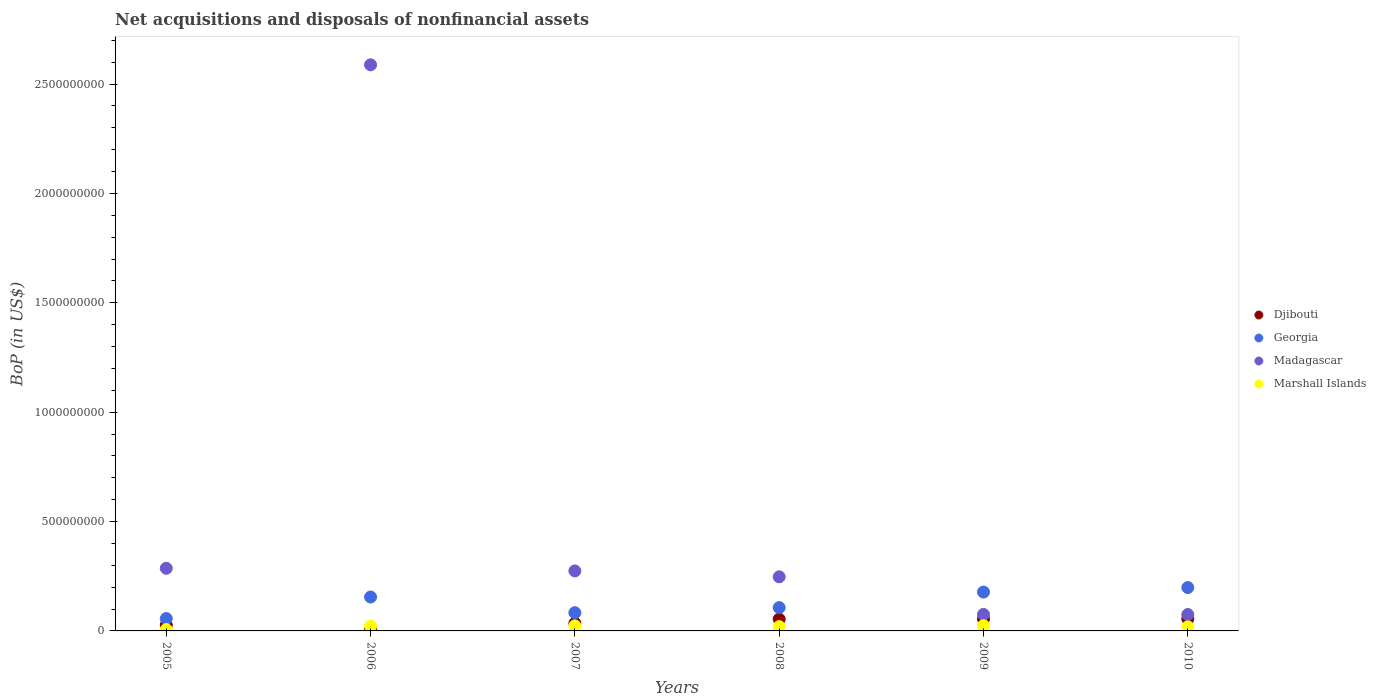How many different coloured dotlines are there?
Your answer should be compact. 4. Is the number of dotlines equal to the number of legend labels?
Make the answer very short. Yes. What is the Balance of Payments in Marshall Islands in 2006?
Make the answer very short. 2.23e+07. Across all years, what is the maximum Balance of Payments in Djibouti?
Provide a succinct answer. 5.53e+07. Across all years, what is the minimum Balance of Payments in Marshall Islands?
Keep it short and to the point. 6.08e+06. In which year was the Balance of Payments in Marshall Islands maximum?
Your response must be concise. 2009. What is the total Balance of Payments in Djibouti in the graph?
Keep it short and to the point. 2.36e+08. What is the difference between the Balance of Payments in Georgia in 2007 and that in 2010?
Ensure brevity in your answer.  -1.15e+08. What is the difference between the Balance of Payments in Marshall Islands in 2009 and the Balance of Payments in Madagascar in 2008?
Keep it short and to the point. -2.24e+08. What is the average Balance of Payments in Djibouti per year?
Offer a terse response. 3.93e+07. In the year 2005, what is the difference between the Balance of Payments in Marshall Islands and Balance of Payments in Georgia?
Provide a succinct answer. -5.04e+07. What is the ratio of the Balance of Payments in Madagascar in 2008 to that in 2010?
Your answer should be compact. 3.3. Is the Balance of Payments in Madagascar in 2005 less than that in 2007?
Offer a terse response. No. Is the difference between the Balance of Payments in Marshall Islands in 2005 and 2008 greater than the difference between the Balance of Payments in Georgia in 2005 and 2008?
Offer a very short reply. Yes. What is the difference between the highest and the second highest Balance of Payments in Madagascar?
Your answer should be very brief. 2.30e+09. What is the difference between the highest and the lowest Balance of Payments in Georgia?
Give a very brief answer. 1.42e+08. Is the sum of the Balance of Payments in Djibouti in 2006 and 2007 greater than the maximum Balance of Payments in Madagascar across all years?
Your answer should be compact. No. Does the Balance of Payments in Georgia monotonically increase over the years?
Provide a succinct answer. No. Is the Balance of Payments in Georgia strictly less than the Balance of Payments in Marshall Islands over the years?
Provide a short and direct response. No. How many dotlines are there?
Offer a very short reply. 4. How many years are there in the graph?
Ensure brevity in your answer.  6. Are the values on the major ticks of Y-axis written in scientific E-notation?
Offer a terse response. No. Does the graph contain any zero values?
Your response must be concise. No. Does the graph contain grids?
Provide a succinct answer. No. How are the legend labels stacked?
Offer a very short reply. Vertical. What is the title of the graph?
Keep it short and to the point. Net acquisitions and disposals of nonfinancial assets. Does "Austria" appear as one of the legend labels in the graph?
Provide a succinct answer. No. What is the label or title of the Y-axis?
Offer a very short reply. BoP (in US$). What is the BoP (in US$) of Djibouti in 2005?
Ensure brevity in your answer.  2.68e+07. What is the BoP (in US$) in Georgia in 2005?
Keep it short and to the point. 5.65e+07. What is the BoP (in US$) of Madagascar in 2005?
Offer a very short reply. 2.86e+08. What is the BoP (in US$) in Marshall Islands in 2005?
Your answer should be very brief. 6.08e+06. What is the BoP (in US$) of Djibouti in 2006?
Provide a succinct answer. 9.31e+06. What is the BoP (in US$) of Georgia in 2006?
Ensure brevity in your answer.  1.55e+08. What is the BoP (in US$) in Madagascar in 2006?
Make the answer very short. 2.59e+09. What is the BoP (in US$) in Marshall Islands in 2006?
Keep it short and to the point. 2.23e+07. What is the BoP (in US$) of Djibouti in 2007?
Your response must be concise. 3.53e+07. What is the BoP (in US$) of Georgia in 2007?
Offer a very short reply. 8.34e+07. What is the BoP (in US$) in Madagascar in 2007?
Ensure brevity in your answer.  2.74e+08. What is the BoP (in US$) in Marshall Islands in 2007?
Keep it short and to the point. 2.32e+07. What is the BoP (in US$) in Djibouti in 2008?
Your answer should be very brief. 5.37e+07. What is the BoP (in US$) in Georgia in 2008?
Your answer should be compact. 1.07e+08. What is the BoP (in US$) in Madagascar in 2008?
Your response must be concise. 2.47e+08. What is the BoP (in US$) of Marshall Islands in 2008?
Ensure brevity in your answer.  1.97e+07. What is the BoP (in US$) of Djibouti in 2009?
Offer a very short reply. 5.51e+07. What is the BoP (in US$) in Georgia in 2009?
Provide a short and direct response. 1.78e+08. What is the BoP (in US$) of Madagascar in 2009?
Offer a very short reply. 7.55e+07. What is the BoP (in US$) in Marshall Islands in 2009?
Your answer should be very brief. 2.38e+07. What is the BoP (in US$) in Djibouti in 2010?
Keep it short and to the point. 5.53e+07. What is the BoP (in US$) in Georgia in 2010?
Make the answer very short. 1.98e+08. What is the BoP (in US$) in Madagascar in 2010?
Keep it short and to the point. 7.49e+07. What is the BoP (in US$) in Marshall Islands in 2010?
Keep it short and to the point. 1.86e+07. Across all years, what is the maximum BoP (in US$) in Djibouti?
Your answer should be very brief. 5.53e+07. Across all years, what is the maximum BoP (in US$) in Georgia?
Keep it short and to the point. 1.98e+08. Across all years, what is the maximum BoP (in US$) in Madagascar?
Your answer should be very brief. 2.59e+09. Across all years, what is the maximum BoP (in US$) in Marshall Islands?
Your response must be concise. 2.38e+07. Across all years, what is the minimum BoP (in US$) in Djibouti?
Your answer should be very brief. 9.31e+06. Across all years, what is the minimum BoP (in US$) in Georgia?
Give a very brief answer. 5.65e+07. Across all years, what is the minimum BoP (in US$) in Madagascar?
Your answer should be compact. 7.49e+07. Across all years, what is the minimum BoP (in US$) in Marshall Islands?
Provide a succinct answer. 6.08e+06. What is the total BoP (in US$) of Djibouti in the graph?
Provide a short and direct response. 2.36e+08. What is the total BoP (in US$) in Georgia in the graph?
Provide a short and direct response. 7.77e+08. What is the total BoP (in US$) of Madagascar in the graph?
Provide a short and direct response. 3.55e+09. What is the total BoP (in US$) of Marshall Islands in the graph?
Provide a short and direct response. 1.14e+08. What is the difference between the BoP (in US$) in Djibouti in 2005 and that in 2006?
Give a very brief answer. 1.75e+07. What is the difference between the BoP (in US$) in Georgia in 2005 and that in 2006?
Your answer should be compact. -9.86e+07. What is the difference between the BoP (in US$) in Madagascar in 2005 and that in 2006?
Provide a succinct answer. -2.30e+09. What is the difference between the BoP (in US$) in Marshall Islands in 2005 and that in 2006?
Provide a succinct answer. -1.63e+07. What is the difference between the BoP (in US$) of Djibouti in 2005 and that in 2007?
Provide a succinct answer. -8.50e+06. What is the difference between the BoP (in US$) in Georgia in 2005 and that in 2007?
Your response must be concise. -2.69e+07. What is the difference between the BoP (in US$) in Madagascar in 2005 and that in 2007?
Keep it short and to the point. 1.21e+07. What is the difference between the BoP (in US$) of Marshall Islands in 2005 and that in 2007?
Your response must be concise. -1.72e+07. What is the difference between the BoP (in US$) in Djibouti in 2005 and that in 2008?
Ensure brevity in your answer.  -2.70e+07. What is the difference between the BoP (in US$) in Georgia in 2005 and that in 2008?
Offer a terse response. -5.01e+07. What is the difference between the BoP (in US$) in Madagascar in 2005 and that in 2008?
Ensure brevity in your answer.  3.89e+07. What is the difference between the BoP (in US$) in Marshall Islands in 2005 and that in 2008?
Offer a terse response. -1.36e+07. What is the difference between the BoP (in US$) in Djibouti in 2005 and that in 2009?
Your answer should be compact. -2.84e+07. What is the difference between the BoP (in US$) of Georgia in 2005 and that in 2009?
Provide a short and direct response. -1.21e+08. What is the difference between the BoP (in US$) in Madagascar in 2005 and that in 2009?
Your answer should be compact. 2.11e+08. What is the difference between the BoP (in US$) of Marshall Islands in 2005 and that in 2009?
Offer a terse response. -1.77e+07. What is the difference between the BoP (in US$) of Djibouti in 2005 and that in 2010?
Make the answer very short. -2.86e+07. What is the difference between the BoP (in US$) in Georgia in 2005 and that in 2010?
Provide a short and direct response. -1.42e+08. What is the difference between the BoP (in US$) in Madagascar in 2005 and that in 2010?
Ensure brevity in your answer.  2.11e+08. What is the difference between the BoP (in US$) of Marshall Islands in 2005 and that in 2010?
Provide a succinct answer. -1.26e+07. What is the difference between the BoP (in US$) in Djibouti in 2006 and that in 2007?
Offer a very short reply. -2.60e+07. What is the difference between the BoP (in US$) in Georgia in 2006 and that in 2007?
Offer a very short reply. 7.17e+07. What is the difference between the BoP (in US$) of Madagascar in 2006 and that in 2007?
Ensure brevity in your answer.  2.31e+09. What is the difference between the BoP (in US$) in Marshall Islands in 2006 and that in 2007?
Offer a terse response. -9.06e+05. What is the difference between the BoP (in US$) in Djibouti in 2006 and that in 2008?
Offer a very short reply. -4.44e+07. What is the difference between the BoP (in US$) in Georgia in 2006 and that in 2008?
Your response must be concise. 4.85e+07. What is the difference between the BoP (in US$) in Madagascar in 2006 and that in 2008?
Your response must be concise. 2.34e+09. What is the difference between the BoP (in US$) of Marshall Islands in 2006 and that in 2008?
Give a very brief answer. 2.67e+06. What is the difference between the BoP (in US$) in Djibouti in 2006 and that in 2009?
Offer a terse response. -4.58e+07. What is the difference between the BoP (in US$) of Georgia in 2006 and that in 2009?
Your response must be concise. -2.25e+07. What is the difference between the BoP (in US$) in Madagascar in 2006 and that in 2009?
Provide a succinct answer. 2.51e+09. What is the difference between the BoP (in US$) of Marshall Islands in 2006 and that in 2009?
Make the answer very short. -1.47e+06. What is the difference between the BoP (in US$) of Djibouti in 2006 and that in 2010?
Your answer should be very brief. -4.60e+07. What is the difference between the BoP (in US$) in Georgia in 2006 and that in 2010?
Provide a short and direct response. -4.32e+07. What is the difference between the BoP (in US$) in Madagascar in 2006 and that in 2010?
Give a very brief answer. 2.51e+09. What is the difference between the BoP (in US$) in Marshall Islands in 2006 and that in 2010?
Ensure brevity in your answer.  3.70e+06. What is the difference between the BoP (in US$) in Djibouti in 2007 and that in 2008?
Provide a short and direct response. -1.85e+07. What is the difference between the BoP (in US$) in Georgia in 2007 and that in 2008?
Your answer should be compact. -2.32e+07. What is the difference between the BoP (in US$) of Madagascar in 2007 and that in 2008?
Make the answer very short. 2.68e+07. What is the difference between the BoP (in US$) of Marshall Islands in 2007 and that in 2008?
Provide a short and direct response. 3.57e+06. What is the difference between the BoP (in US$) of Djibouti in 2007 and that in 2009?
Your answer should be very brief. -1.99e+07. What is the difference between the BoP (in US$) of Georgia in 2007 and that in 2009?
Make the answer very short. -9.42e+07. What is the difference between the BoP (in US$) of Madagascar in 2007 and that in 2009?
Give a very brief answer. 1.99e+08. What is the difference between the BoP (in US$) of Marshall Islands in 2007 and that in 2009?
Provide a succinct answer. -5.65e+05. What is the difference between the BoP (in US$) in Djibouti in 2007 and that in 2010?
Ensure brevity in your answer.  -2.00e+07. What is the difference between the BoP (in US$) in Georgia in 2007 and that in 2010?
Provide a succinct answer. -1.15e+08. What is the difference between the BoP (in US$) in Madagascar in 2007 and that in 2010?
Ensure brevity in your answer.  1.99e+08. What is the difference between the BoP (in US$) of Marshall Islands in 2007 and that in 2010?
Keep it short and to the point. 4.61e+06. What is the difference between the BoP (in US$) of Djibouti in 2008 and that in 2009?
Your response must be concise. -1.39e+06. What is the difference between the BoP (in US$) of Georgia in 2008 and that in 2009?
Offer a terse response. -7.10e+07. What is the difference between the BoP (in US$) of Madagascar in 2008 and that in 2009?
Your response must be concise. 1.72e+08. What is the difference between the BoP (in US$) of Marshall Islands in 2008 and that in 2009?
Give a very brief answer. -4.14e+06. What is the difference between the BoP (in US$) of Djibouti in 2008 and that in 2010?
Provide a short and direct response. -1.58e+06. What is the difference between the BoP (in US$) in Georgia in 2008 and that in 2010?
Give a very brief answer. -9.17e+07. What is the difference between the BoP (in US$) of Madagascar in 2008 and that in 2010?
Provide a succinct answer. 1.72e+08. What is the difference between the BoP (in US$) in Marshall Islands in 2008 and that in 2010?
Your answer should be compact. 1.04e+06. What is the difference between the BoP (in US$) in Djibouti in 2009 and that in 2010?
Provide a succinct answer. -1.86e+05. What is the difference between the BoP (in US$) of Georgia in 2009 and that in 2010?
Make the answer very short. -2.07e+07. What is the difference between the BoP (in US$) in Madagascar in 2009 and that in 2010?
Your answer should be compact. 5.31e+05. What is the difference between the BoP (in US$) in Marshall Islands in 2009 and that in 2010?
Ensure brevity in your answer.  5.17e+06. What is the difference between the BoP (in US$) of Djibouti in 2005 and the BoP (in US$) of Georgia in 2006?
Provide a succinct answer. -1.28e+08. What is the difference between the BoP (in US$) of Djibouti in 2005 and the BoP (in US$) of Madagascar in 2006?
Your answer should be very brief. -2.56e+09. What is the difference between the BoP (in US$) in Djibouti in 2005 and the BoP (in US$) in Marshall Islands in 2006?
Make the answer very short. 4.43e+06. What is the difference between the BoP (in US$) in Georgia in 2005 and the BoP (in US$) in Madagascar in 2006?
Give a very brief answer. -2.53e+09. What is the difference between the BoP (in US$) of Georgia in 2005 and the BoP (in US$) of Marshall Islands in 2006?
Your response must be concise. 3.41e+07. What is the difference between the BoP (in US$) in Madagascar in 2005 and the BoP (in US$) in Marshall Islands in 2006?
Provide a succinct answer. 2.64e+08. What is the difference between the BoP (in US$) in Djibouti in 2005 and the BoP (in US$) in Georgia in 2007?
Your answer should be very brief. -5.66e+07. What is the difference between the BoP (in US$) in Djibouti in 2005 and the BoP (in US$) in Madagascar in 2007?
Offer a terse response. -2.47e+08. What is the difference between the BoP (in US$) in Djibouti in 2005 and the BoP (in US$) in Marshall Islands in 2007?
Ensure brevity in your answer.  3.52e+06. What is the difference between the BoP (in US$) of Georgia in 2005 and the BoP (in US$) of Madagascar in 2007?
Give a very brief answer. -2.18e+08. What is the difference between the BoP (in US$) of Georgia in 2005 and the BoP (in US$) of Marshall Islands in 2007?
Make the answer very short. 3.32e+07. What is the difference between the BoP (in US$) of Madagascar in 2005 and the BoP (in US$) of Marshall Islands in 2007?
Your answer should be compact. 2.63e+08. What is the difference between the BoP (in US$) in Djibouti in 2005 and the BoP (in US$) in Georgia in 2008?
Provide a succinct answer. -7.99e+07. What is the difference between the BoP (in US$) of Djibouti in 2005 and the BoP (in US$) of Madagascar in 2008?
Your response must be concise. -2.21e+08. What is the difference between the BoP (in US$) of Djibouti in 2005 and the BoP (in US$) of Marshall Islands in 2008?
Your response must be concise. 7.09e+06. What is the difference between the BoP (in US$) of Georgia in 2005 and the BoP (in US$) of Madagascar in 2008?
Offer a terse response. -1.91e+08. What is the difference between the BoP (in US$) of Georgia in 2005 and the BoP (in US$) of Marshall Islands in 2008?
Provide a succinct answer. 3.68e+07. What is the difference between the BoP (in US$) of Madagascar in 2005 and the BoP (in US$) of Marshall Islands in 2008?
Give a very brief answer. 2.67e+08. What is the difference between the BoP (in US$) in Djibouti in 2005 and the BoP (in US$) in Georgia in 2009?
Provide a succinct answer. -1.51e+08. What is the difference between the BoP (in US$) of Djibouti in 2005 and the BoP (in US$) of Madagascar in 2009?
Offer a terse response. -4.87e+07. What is the difference between the BoP (in US$) of Djibouti in 2005 and the BoP (in US$) of Marshall Islands in 2009?
Provide a short and direct response. 2.96e+06. What is the difference between the BoP (in US$) in Georgia in 2005 and the BoP (in US$) in Madagascar in 2009?
Ensure brevity in your answer.  -1.90e+07. What is the difference between the BoP (in US$) in Georgia in 2005 and the BoP (in US$) in Marshall Islands in 2009?
Give a very brief answer. 3.27e+07. What is the difference between the BoP (in US$) of Madagascar in 2005 and the BoP (in US$) of Marshall Islands in 2009?
Your response must be concise. 2.63e+08. What is the difference between the BoP (in US$) of Djibouti in 2005 and the BoP (in US$) of Georgia in 2010?
Your answer should be compact. -1.72e+08. What is the difference between the BoP (in US$) of Djibouti in 2005 and the BoP (in US$) of Madagascar in 2010?
Your response must be concise. -4.82e+07. What is the difference between the BoP (in US$) of Djibouti in 2005 and the BoP (in US$) of Marshall Islands in 2010?
Ensure brevity in your answer.  8.13e+06. What is the difference between the BoP (in US$) in Georgia in 2005 and the BoP (in US$) in Madagascar in 2010?
Provide a short and direct response. -1.85e+07. What is the difference between the BoP (in US$) of Georgia in 2005 and the BoP (in US$) of Marshall Islands in 2010?
Give a very brief answer. 3.78e+07. What is the difference between the BoP (in US$) in Madagascar in 2005 and the BoP (in US$) in Marshall Islands in 2010?
Your answer should be very brief. 2.68e+08. What is the difference between the BoP (in US$) in Djibouti in 2006 and the BoP (in US$) in Georgia in 2007?
Your answer should be compact. -7.41e+07. What is the difference between the BoP (in US$) in Djibouti in 2006 and the BoP (in US$) in Madagascar in 2007?
Provide a succinct answer. -2.65e+08. What is the difference between the BoP (in US$) of Djibouti in 2006 and the BoP (in US$) of Marshall Islands in 2007?
Keep it short and to the point. -1.39e+07. What is the difference between the BoP (in US$) in Georgia in 2006 and the BoP (in US$) in Madagascar in 2007?
Your answer should be compact. -1.19e+08. What is the difference between the BoP (in US$) of Georgia in 2006 and the BoP (in US$) of Marshall Islands in 2007?
Give a very brief answer. 1.32e+08. What is the difference between the BoP (in US$) in Madagascar in 2006 and the BoP (in US$) in Marshall Islands in 2007?
Give a very brief answer. 2.56e+09. What is the difference between the BoP (in US$) of Djibouti in 2006 and the BoP (in US$) of Georgia in 2008?
Offer a very short reply. -9.73e+07. What is the difference between the BoP (in US$) in Djibouti in 2006 and the BoP (in US$) in Madagascar in 2008?
Provide a short and direct response. -2.38e+08. What is the difference between the BoP (in US$) in Djibouti in 2006 and the BoP (in US$) in Marshall Islands in 2008?
Give a very brief answer. -1.04e+07. What is the difference between the BoP (in US$) of Georgia in 2006 and the BoP (in US$) of Madagascar in 2008?
Your response must be concise. -9.23e+07. What is the difference between the BoP (in US$) of Georgia in 2006 and the BoP (in US$) of Marshall Islands in 2008?
Provide a short and direct response. 1.35e+08. What is the difference between the BoP (in US$) of Madagascar in 2006 and the BoP (in US$) of Marshall Islands in 2008?
Give a very brief answer. 2.57e+09. What is the difference between the BoP (in US$) in Djibouti in 2006 and the BoP (in US$) in Georgia in 2009?
Your answer should be compact. -1.68e+08. What is the difference between the BoP (in US$) of Djibouti in 2006 and the BoP (in US$) of Madagascar in 2009?
Your answer should be compact. -6.62e+07. What is the difference between the BoP (in US$) in Djibouti in 2006 and the BoP (in US$) in Marshall Islands in 2009?
Offer a terse response. -1.45e+07. What is the difference between the BoP (in US$) in Georgia in 2006 and the BoP (in US$) in Madagascar in 2009?
Make the answer very short. 7.96e+07. What is the difference between the BoP (in US$) of Georgia in 2006 and the BoP (in US$) of Marshall Islands in 2009?
Your answer should be compact. 1.31e+08. What is the difference between the BoP (in US$) in Madagascar in 2006 and the BoP (in US$) in Marshall Islands in 2009?
Your answer should be compact. 2.56e+09. What is the difference between the BoP (in US$) of Djibouti in 2006 and the BoP (in US$) of Georgia in 2010?
Ensure brevity in your answer.  -1.89e+08. What is the difference between the BoP (in US$) in Djibouti in 2006 and the BoP (in US$) in Madagascar in 2010?
Your response must be concise. -6.56e+07. What is the difference between the BoP (in US$) in Djibouti in 2006 and the BoP (in US$) in Marshall Islands in 2010?
Offer a very short reply. -9.33e+06. What is the difference between the BoP (in US$) of Georgia in 2006 and the BoP (in US$) of Madagascar in 2010?
Keep it short and to the point. 8.02e+07. What is the difference between the BoP (in US$) in Georgia in 2006 and the BoP (in US$) in Marshall Islands in 2010?
Offer a very short reply. 1.36e+08. What is the difference between the BoP (in US$) in Madagascar in 2006 and the BoP (in US$) in Marshall Islands in 2010?
Provide a succinct answer. 2.57e+09. What is the difference between the BoP (in US$) in Djibouti in 2007 and the BoP (in US$) in Georgia in 2008?
Provide a short and direct response. -7.14e+07. What is the difference between the BoP (in US$) in Djibouti in 2007 and the BoP (in US$) in Madagascar in 2008?
Ensure brevity in your answer.  -2.12e+08. What is the difference between the BoP (in US$) in Djibouti in 2007 and the BoP (in US$) in Marshall Islands in 2008?
Your answer should be compact. 1.56e+07. What is the difference between the BoP (in US$) in Georgia in 2007 and the BoP (in US$) in Madagascar in 2008?
Your answer should be compact. -1.64e+08. What is the difference between the BoP (in US$) of Georgia in 2007 and the BoP (in US$) of Marshall Islands in 2008?
Make the answer very short. 6.37e+07. What is the difference between the BoP (in US$) of Madagascar in 2007 and the BoP (in US$) of Marshall Islands in 2008?
Your answer should be compact. 2.55e+08. What is the difference between the BoP (in US$) of Djibouti in 2007 and the BoP (in US$) of Georgia in 2009?
Your answer should be very brief. -1.42e+08. What is the difference between the BoP (in US$) in Djibouti in 2007 and the BoP (in US$) in Madagascar in 2009?
Provide a short and direct response. -4.02e+07. What is the difference between the BoP (in US$) of Djibouti in 2007 and the BoP (in US$) of Marshall Islands in 2009?
Ensure brevity in your answer.  1.15e+07. What is the difference between the BoP (in US$) in Georgia in 2007 and the BoP (in US$) in Madagascar in 2009?
Your answer should be very brief. 7.93e+06. What is the difference between the BoP (in US$) of Georgia in 2007 and the BoP (in US$) of Marshall Islands in 2009?
Your answer should be very brief. 5.96e+07. What is the difference between the BoP (in US$) in Madagascar in 2007 and the BoP (in US$) in Marshall Islands in 2009?
Provide a succinct answer. 2.50e+08. What is the difference between the BoP (in US$) in Djibouti in 2007 and the BoP (in US$) in Georgia in 2010?
Make the answer very short. -1.63e+08. What is the difference between the BoP (in US$) in Djibouti in 2007 and the BoP (in US$) in Madagascar in 2010?
Make the answer very short. -3.97e+07. What is the difference between the BoP (in US$) in Djibouti in 2007 and the BoP (in US$) in Marshall Islands in 2010?
Your answer should be compact. 1.66e+07. What is the difference between the BoP (in US$) of Georgia in 2007 and the BoP (in US$) of Madagascar in 2010?
Provide a succinct answer. 8.46e+06. What is the difference between the BoP (in US$) in Georgia in 2007 and the BoP (in US$) in Marshall Islands in 2010?
Provide a succinct answer. 6.48e+07. What is the difference between the BoP (in US$) of Madagascar in 2007 and the BoP (in US$) of Marshall Islands in 2010?
Your answer should be compact. 2.56e+08. What is the difference between the BoP (in US$) of Djibouti in 2008 and the BoP (in US$) of Georgia in 2009?
Ensure brevity in your answer.  -1.24e+08. What is the difference between the BoP (in US$) in Djibouti in 2008 and the BoP (in US$) in Madagascar in 2009?
Your answer should be compact. -2.17e+07. What is the difference between the BoP (in US$) in Djibouti in 2008 and the BoP (in US$) in Marshall Islands in 2009?
Give a very brief answer. 2.99e+07. What is the difference between the BoP (in US$) of Georgia in 2008 and the BoP (in US$) of Madagascar in 2009?
Keep it short and to the point. 3.12e+07. What is the difference between the BoP (in US$) of Georgia in 2008 and the BoP (in US$) of Marshall Islands in 2009?
Your answer should be compact. 8.28e+07. What is the difference between the BoP (in US$) in Madagascar in 2008 and the BoP (in US$) in Marshall Islands in 2009?
Your answer should be compact. 2.24e+08. What is the difference between the BoP (in US$) of Djibouti in 2008 and the BoP (in US$) of Georgia in 2010?
Your answer should be compact. -1.45e+08. What is the difference between the BoP (in US$) of Djibouti in 2008 and the BoP (in US$) of Madagascar in 2010?
Your response must be concise. -2.12e+07. What is the difference between the BoP (in US$) of Djibouti in 2008 and the BoP (in US$) of Marshall Islands in 2010?
Ensure brevity in your answer.  3.51e+07. What is the difference between the BoP (in US$) of Georgia in 2008 and the BoP (in US$) of Madagascar in 2010?
Your answer should be very brief. 3.17e+07. What is the difference between the BoP (in US$) in Georgia in 2008 and the BoP (in US$) in Marshall Islands in 2010?
Offer a terse response. 8.80e+07. What is the difference between the BoP (in US$) of Madagascar in 2008 and the BoP (in US$) of Marshall Islands in 2010?
Keep it short and to the point. 2.29e+08. What is the difference between the BoP (in US$) of Djibouti in 2009 and the BoP (in US$) of Georgia in 2010?
Offer a very short reply. -1.43e+08. What is the difference between the BoP (in US$) in Djibouti in 2009 and the BoP (in US$) in Madagascar in 2010?
Your answer should be very brief. -1.98e+07. What is the difference between the BoP (in US$) in Djibouti in 2009 and the BoP (in US$) in Marshall Islands in 2010?
Give a very brief answer. 3.65e+07. What is the difference between the BoP (in US$) in Georgia in 2009 and the BoP (in US$) in Madagascar in 2010?
Your answer should be compact. 1.03e+08. What is the difference between the BoP (in US$) in Georgia in 2009 and the BoP (in US$) in Marshall Islands in 2010?
Ensure brevity in your answer.  1.59e+08. What is the difference between the BoP (in US$) of Madagascar in 2009 and the BoP (in US$) of Marshall Islands in 2010?
Ensure brevity in your answer.  5.68e+07. What is the average BoP (in US$) in Djibouti per year?
Your response must be concise. 3.93e+07. What is the average BoP (in US$) in Georgia per year?
Keep it short and to the point. 1.30e+08. What is the average BoP (in US$) in Madagascar per year?
Your response must be concise. 5.91e+08. What is the average BoP (in US$) of Marshall Islands per year?
Keep it short and to the point. 1.90e+07. In the year 2005, what is the difference between the BoP (in US$) in Djibouti and BoP (in US$) in Georgia?
Give a very brief answer. -2.97e+07. In the year 2005, what is the difference between the BoP (in US$) of Djibouti and BoP (in US$) of Madagascar?
Make the answer very short. -2.60e+08. In the year 2005, what is the difference between the BoP (in US$) of Djibouti and BoP (in US$) of Marshall Islands?
Make the answer very short. 2.07e+07. In the year 2005, what is the difference between the BoP (in US$) in Georgia and BoP (in US$) in Madagascar?
Make the answer very short. -2.30e+08. In the year 2005, what is the difference between the BoP (in US$) of Georgia and BoP (in US$) of Marshall Islands?
Ensure brevity in your answer.  5.04e+07. In the year 2005, what is the difference between the BoP (in US$) in Madagascar and BoP (in US$) in Marshall Islands?
Provide a short and direct response. 2.80e+08. In the year 2006, what is the difference between the BoP (in US$) in Djibouti and BoP (in US$) in Georgia?
Give a very brief answer. -1.46e+08. In the year 2006, what is the difference between the BoP (in US$) in Djibouti and BoP (in US$) in Madagascar?
Your answer should be very brief. -2.58e+09. In the year 2006, what is the difference between the BoP (in US$) in Djibouti and BoP (in US$) in Marshall Islands?
Your answer should be very brief. -1.30e+07. In the year 2006, what is the difference between the BoP (in US$) in Georgia and BoP (in US$) in Madagascar?
Offer a terse response. -2.43e+09. In the year 2006, what is the difference between the BoP (in US$) of Georgia and BoP (in US$) of Marshall Islands?
Make the answer very short. 1.33e+08. In the year 2006, what is the difference between the BoP (in US$) in Madagascar and BoP (in US$) in Marshall Islands?
Offer a terse response. 2.57e+09. In the year 2007, what is the difference between the BoP (in US$) in Djibouti and BoP (in US$) in Georgia?
Ensure brevity in your answer.  -4.81e+07. In the year 2007, what is the difference between the BoP (in US$) of Djibouti and BoP (in US$) of Madagascar?
Ensure brevity in your answer.  -2.39e+08. In the year 2007, what is the difference between the BoP (in US$) of Djibouti and BoP (in US$) of Marshall Islands?
Your answer should be very brief. 1.20e+07. In the year 2007, what is the difference between the BoP (in US$) in Georgia and BoP (in US$) in Madagascar?
Keep it short and to the point. -1.91e+08. In the year 2007, what is the difference between the BoP (in US$) of Georgia and BoP (in US$) of Marshall Islands?
Make the answer very short. 6.02e+07. In the year 2007, what is the difference between the BoP (in US$) in Madagascar and BoP (in US$) in Marshall Islands?
Provide a succinct answer. 2.51e+08. In the year 2008, what is the difference between the BoP (in US$) in Djibouti and BoP (in US$) in Georgia?
Keep it short and to the point. -5.29e+07. In the year 2008, what is the difference between the BoP (in US$) in Djibouti and BoP (in US$) in Madagascar?
Provide a succinct answer. -1.94e+08. In the year 2008, what is the difference between the BoP (in US$) in Djibouti and BoP (in US$) in Marshall Islands?
Your response must be concise. 3.41e+07. In the year 2008, what is the difference between the BoP (in US$) in Georgia and BoP (in US$) in Madagascar?
Your answer should be compact. -1.41e+08. In the year 2008, what is the difference between the BoP (in US$) of Georgia and BoP (in US$) of Marshall Islands?
Provide a short and direct response. 8.69e+07. In the year 2008, what is the difference between the BoP (in US$) of Madagascar and BoP (in US$) of Marshall Islands?
Your answer should be compact. 2.28e+08. In the year 2009, what is the difference between the BoP (in US$) of Djibouti and BoP (in US$) of Georgia?
Your response must be concise. -1.22e+08. In the year 2009, what is the difference between the BoP (in US$) of Djibouti and BoP (in US$) of Madagascar?
Your answer should be compact. -2.03e+07. In the year 2009, what is the difference between the BoP (in US$) of Djibouti and BoP (in US$) of Marshall Islands?
Your answer should be very brief. 3.13e+07. In the year 2009, what is the difference between the BoP (in US$) of Georgia and BoP (in US$) of Madagascar?
Ensure brevity in your answer.  1.02e+08. In the year 2009, what is the difference between the BoP (in US$) in Georgia and BoP (in US$) in Marshall Islands?
Give a very brief answer. 1.54e+08. In the year 2009, what is the difference between the BoP (in US$) in Madagascar and BoP (in US$) in Marshall Islands?
Your response must be concise. 5.17e+07. In the year 2010, what is the difference between the BoP (in US$) in Djibouti and BoP (in US$) in Georgia?
Offer a terse response. -1.43e+08. In the year 2010, what is the difference between the BoP (in US$) in Djibouti and BoP (in US$) in Madagascar?
Provide a short and direct response. -1.96e+07. In the year 2010, what is the difference between the BoP (in US$) in Djibouti and BoP (in US$) in Marshall Islands?
Provide a short and direct response. 3.67e+07. In the year 2010, what is the difference between the BoP (in US$) in Georgia and BoP (in US$) in Madagascar?
Your answer should be compact. 1.23e+08. In the year 2010, what is the difference between the BoP (in US$) in Georgia and BoP (in US$) in Marshall Islands?
Make the answer very short. 1.80e+08. In the year 2010, what is the difference between the BoP (in US$) of Madagascar and BoP (in US$) of Marshall Islands?
Your response must be concise. 5.63e+07. What is the ratio of the BoP (in US$) of Djibouti in 2005 to that in 2006?
Offer a very short reply. 2.87. What is the ratio of the BoP (in US$) in Georgia in 2005 to that in 2006?
Offer a terse response. 0.36. What is the ratio of the BoP (in US$) in Madagascar in 2005 to that in 2006?
Offer a very short reply. 0.11. What is the ratio of the BoP (in US$) of Marshall Islands in 2005 to that in 2006?
Offer a very short reply. 0.27. What is the ratio of the BoP (in US$) of Djibouti in 2005 to that in 2007?
Your response must be concise. 0.76. What is the ratio of the BoP (in US$) of Georgia in 2005 to that in 2007?
Keep it short and to the point. 0.68. What is the ratio of the BoP (in US$) of Madagascar in 2005 to that in 2007?
Make the answer very short. 1.04. What is the ratio of the BoP (in US$) of Marshall Islands in 2005 to that in 2007?
Ensure brevity in your answer.  0.26. What is the ratio of the BoP (in US$) in Djibouti in 2005 to that in 2008?
Keep it short and to the point. 0.5. What is the ratio of the BoP (in US$) of Georgia in 2005 to that in 2008?
Offer a very short reply. 0.53. What is the ratio of the BoP (in US$) of Madagascar in 2005 to that in 2008?
Provide a succinct answer. 1.16. What is the ratio of the BoP (in US$) of Marshall Islands in 2005 to that in 2008?
Offer a terse response. 0.31. What is the ratio of the BoP (in US$) in Djibouti in 2005 to that in 2009?
Make the answer very short. 0.49. What is the ratio of the BoP (in US$) in Georgia in 2005 to that in 2009?
Your answer should be compact. 0.32. What is the ratio of the BoP (in US$) in Madagascar in 2005 to that in 2009?
Provide a succinct answer. 3.79. What is the ratio of the BoP (in US$) of Marshall Islands in 2005 to that in 2009?
Keep it short and to the point. 0.26. What is the ratio of the BoP (in US$) of Djibouti in 2005 to that in 2010?
Give a very brief answer. 0.48. What is the ratio of the BoP (in US$) of Georgia in 2005 to that in 2010?
Make the answer very short. 0.28. What is the ratio of the BoP (in US$) of Madagascar in 2005 to that in 2010?
Make the answer very short. 3.82. What is the ratio of the BoP (in US$) of Marshall Islands in 2005 to that in 2010?
Your answer should be compact. 0.33. What is the ratio of the BoP (in US$) in Djibouti in 2006 to that in 2007?
Offer a very short reply. 0.26. What is the ratio of the BoP (in US$) in Georgia in 2006 to that in 2007?
Offer a terse response. 1.86. What is the ratio of the BoP (in US$) of Madagascar in 2006 to that in 2007?
Keep it short and to the point. 9.44. What is the ratio of the BoP (in US$) of Djibouti in 2006 to that in 2008?
Give a very brief answer. 0.17. What is the ratio of the BoP (in US$) in Georgia in 2006 to that in 2008?
Make the answer very short. 1.45. What is the ratio of the BoP (in US$) of Madagascar in 2006 to that in 2008?
Your answer should be compact. 10.46. What is the ratio of the BoP (in US$) of Marshall Islands in 2006 to that in 2008?
Provide a short and direct response. 1.14. What is the ratio of the BoP (in US$) of Djibouti in 2006 to that in 2009?
Provide a short and direct response. 0.17. What is the ratio of the BoP (in US$) of Georgia in 2006 to that in 2009?
Make the answer very short. 0.87. What is the ratio of the BoP (in US$) of Madagascar in 2006 to that in 2009?
Offer a very short reply. 34.29. What is the ratio of the BoP (in US$) of Marshall Islands in 2006 to that in 2009?
Give a very brief answer. 0.94. What is the ratio of the BoP (in US$) in Djibouti in 2006 to that in 2010?
Your answer should be compact. 0.17. What is the ratio of the BoP (in US$) in Georgia in 2006 to that in 2010?
Your answer should be very brief. 0.78. What is the ratio of the BoP (in US$) in Madagascar in 2006 to that in 2010?
Your answer should be compact. 34.54. What is the ratio of the BoP (in US$) of Marshall Islands in 2006 to that in 2010?
Your answer should be very brief. 1.2. What is the ratio of the BoP (in US$) of Djibouti in 2007 to that in 2008?
Provide a succinct answer. 0.66. What is the ratio of the BoP (in US$) of Georgia in 2007 to that in 2008?
Keep it short and to the point. 0.78. What is the ratio of the BoP (in US$) of Madagascar in 2007 to that in 2008?
Keep it short and to the point. 1.11. What is the ratio of the BoP (in US$) of Marshall Islands in 2007 to that in 2008?
Ensure brevity in your answer.  1.18. What is the ratio of the BoP (in US$) in Djibouti in 2007 to that in 2009?
Your answer should be very brief. 0.64. What is the ratio of the BoP (in US$) of Georgia in 2007 to that in 2009?
Ensure brevity in your answer.  0.47. What is the ratio of the BoP (in US$) in Madagascar in 2007 to that in 2009?
Offer a terse response. 3.63. What is the ratio of the BoP (in US$) in Marshall Islands in 2007 to that in 2009?
Provide a short and direct response. 0.98. What is the ratio of the BoP (in US$) in Djibouti in 2007 to that in 2010?
Provide a succinct answer. 0.64. What is the ratio of the BoP (in US$) in Georgia in 2007 to that in 2010?
Offer a terse response. 0.42. What is the ratio of the BoP (in US$) in Madagascar in 2007 to that in 2010?
Your response must be concise. 3.66. What is the ratio of the BoP (in US$) of Marshall Islands in 2007 to that in 2010?
Provide a succinct answer. 1.25. What is the ratio of the BoP (in US$) in Djibouti in 2008 to that in 2009?
Keep it short and to the point. 0.97. What is the ratio of the BoP (in US$) of Georgia in 2008 to that in 2009?
Provide a succinct answer. 0.6. What is the ratio of the BoP (in US$) in Madagascar in 2008 to that in 2009?
Keep it short and to the point. 3.28. What is the ratio of the BoP (in US$) in Marshall Islands in 2008 to that in 2009?
Your answer should be compact. 0.83. What is the ratio of the BoP (in US$) of Djibouti in 2008 to that in 2010?
Offer a terse response. 0.97. What is the ratio of the BoP (in US$) in Georgia in 2008 to that in 2010?
Keep it short and to the point. 0.54. What is the ratio of the BoP (in US$) in Madagascar in 2008 to that in 2010?
Provide a short and direct response. 3.3. What is the ratio of the BoP (in US$) in Marshall Islands in 2008 to that in 2010?
Provide a succinct answer. 1.06. What is the ratio of the BoP (in US$) in Djibouti in 2009 to that in 2010?
Offer a terse response. 1. What is the ratio of the BoP (in US$) of Georgia in 2009 to that in 2010?
Provide a succinct answer. 0.9. What is the ratio of the BoP (in US$) of Madagascar in 2009 to that in 2010?
Your response must be concise. 1.01. What is the ratio of the BoP (in US$) in Marshall Islands in 2009 to that in 2010?
Your response must be concise. 1.28. What is the difference between the highest and the second highest BoP (in US$) of Djibouti?
Offer a very short reply. 1.86e+05. What is the difference between the highest and the second highest BoP (in US$) of Georgia?
Ensure brevity in your answer.  2.07e+07. What is the difference between the highest and the second highest BoP (in US$) in Madagascar?
Provide a succinct answer. 2.30e+09. What is the difference between the highest and the second highest BoP (in US$) of Marshall Islands?
Offer a very short reply. 5.65e+05. What is the difference between the highest and the lowest BoP (in US$) in Djibouti?
Give a very brief answer. 4.60e+07. What is the difference between the highest and the lowest BoP (in US$) of Georgia?
Offer a very short reply. 1.42e+08. What is the difference between the highest and the lowest BoP (in US$) in Madagascar?
Your response must be concise. 2.51e+09. What is the difference between the highest and the lowest BoP (in US$) in Marshall Islands?
Provide a short and direct response. 1.77e+07. 